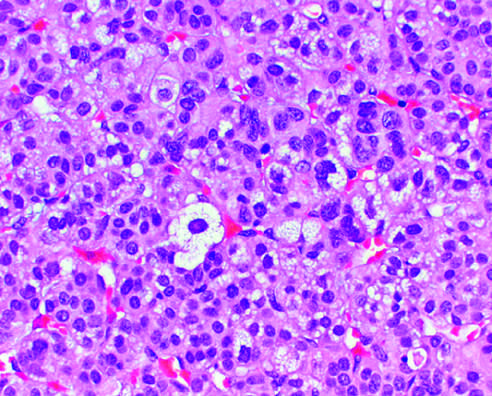re mitotic activity and necrosis not seen?
Answer the question using a single word or phrase. Yes 